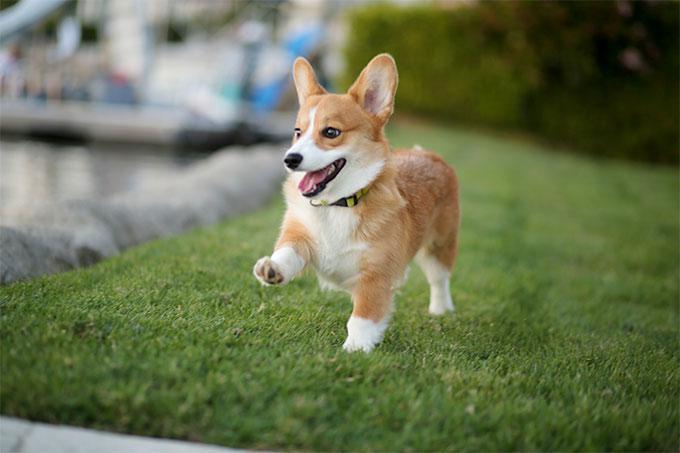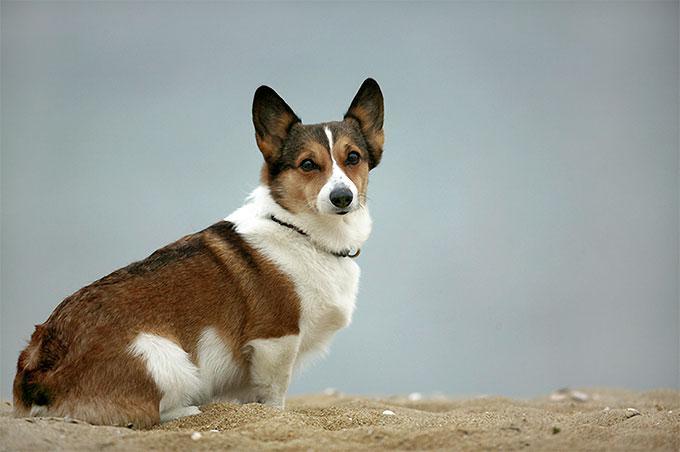The first image is the image on the left, the second image is the image on the right. For the images displayed, is the sentence "All dogs in these images have the same basic pose and fur coloration." factually correct? Answer yes or no. No. The first image is the image on the left, the second image is the image on the right. Assess this claim about the two images: "the dog in the image on the right is in side profile". Correct or not? Answer yes or no. Yes. 